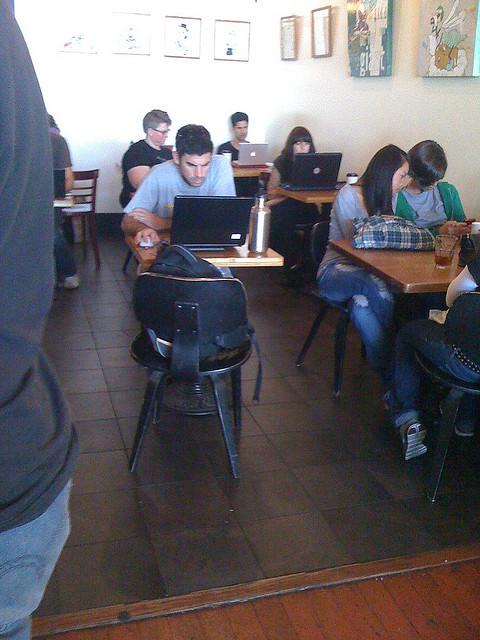What color is the ladies purse on the table?
Answer briefly. Plaid. How many men are in the picture?
Be succinct. 3. What are they doing?
Short answer required. Studying. Where are the frames?
Write a very short answer. On wall. Is there a roof in this room?
Quick response, please. Yes. Is this a hotel?
Short answer required. No. 